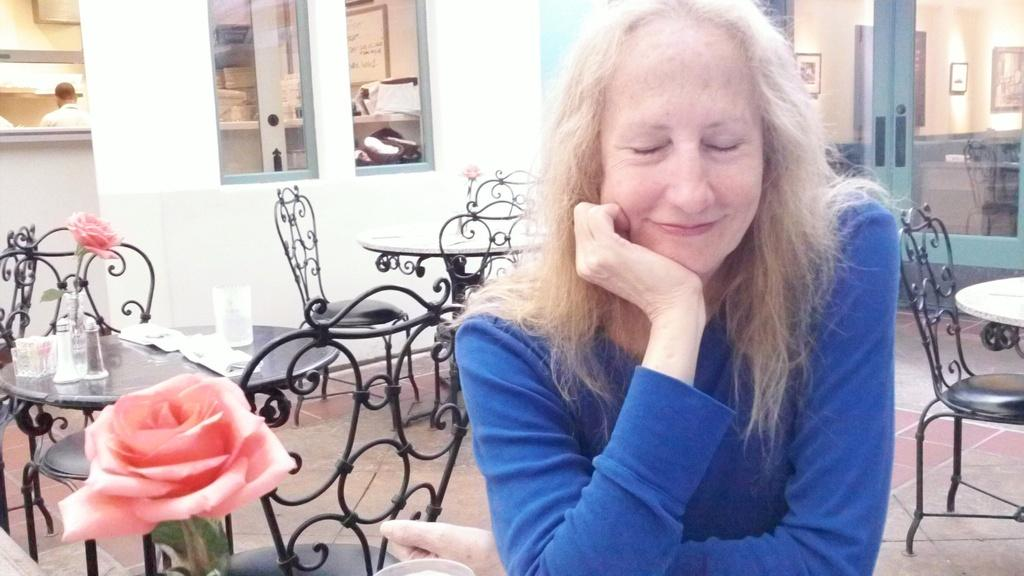What is the woman in the image wearing? The woman is wearing a blue dress. What expression does the woman have? The woman is smiling. What type of furniture can be seen in the image? There are chairs and tables in the image. Can you describe any decorative elements in the image? There is a flower on one of the tables. Is there anyone else visible in the image besides the woman? Yes, a person is standing in the distance. What can be seen on the walls in the image? There are pictures on the wall. What type of trouble is the woman causing with her plate in the image? There is no plate present in the image, and therefore no trouble can be attributed to it. 